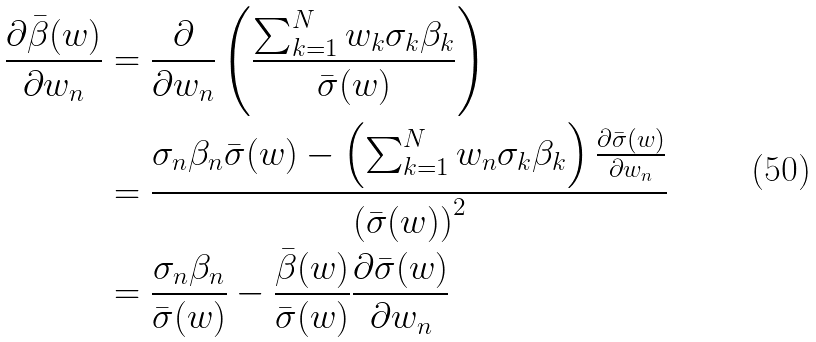Convert formula to latex. <formula><loc_0><loc_0><loc_500><loc_500>\frac { \partial \bar { \beta } ( w ) } { \partial w _ { n } } & = \frac { \partial } { \partial w _ { n } } \left ( \frac { \sum _ { k = 1 } ^ { N } w _ { k } \sigma _ { k } \beta _ { k } } { \bar { \sigma } ( w ) } \right ) \\ & = \frac { \sigma _ { n } \beta _ { n } \bar { \sigma } ( w ) - \left ( \sum _ { k = 1 } ^ { N } w _ { n } \sigma _ { k } \beta _ { k } \right ) \frac { \partial \bar { \sigma } ( w ) } { \partial w _ { n } } } { \left ( \bar { \sigma } ( w ) \right ) ^ { 2 } } \\ & = \frac { \sigma _ { n } \beta _ { n } } { \bar { \sigma } ( w ) } - \frac { \bar { \beta } ( w ) } { \bar { \sigma } ( w ) } \frac { \partial \bar { \sigma } ( w ) } { \partial w _ { n } }</formula> 